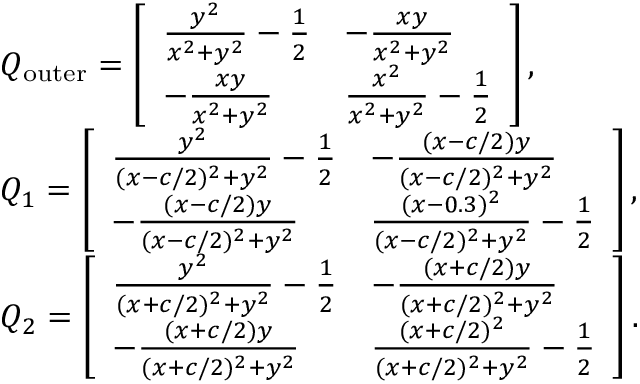Convert formula to latex. <formula><loc_0><loc_0><loc_500><loc_500>\begin{array} { r l } & { Q _ { o u t e r } = \left [ \begin{array} { l l } { \frac { y ^ { 2 } } { x ^ { 2 } + y ^ { 2 } } - \frac { 1 } { 2 } } & { - \frac { x y } { x ^ { 2 } + y ^ { 2 } } } \\ { - \frac { x y } { x ^ { 2 } + y ^ { 2 } } } & { \frac { x ^ { 2 } } { x ^ { 2 } + y ^ { 2 } } - \frac { 1 } { 2 } } \end{array} \right ] , } \\ & { Q _ { 1 } = \left [ \begin{array} { l l } { \frac { y ^ { 2 } } { ( x - c / 2 ) ^ { 2 } + y ^ { 2 } } - \frac { 1 } { 2 } } & { - \frac { ( x - c / 2 ) y } { ( x - c / 2 ) ^ { 2 } + y ^ { 2 } } } \\ { - \frac { ( x - c / 2 ) y } { ( x - c / 2 ) ^ { 2 } + y ^ { 2 } } } & { \frac { ( x - 0 . 3 ) ^ { 2 } } { ( x - c / 2 ) ^ { 2 } + y ^ { 2 } } - \frac { 1 } { 2 } } \end{array} \right ] , } \\ & { Q _ { 2 } = \left [ \begin{array} { l l } { \frac { y ^ { 2 } } { ( x + c / 2 ) ^ { 2 } + y ^ { 2 } } - \frac { 1 } { 2 } } & { - \frac { ( x + c / 2 ) y } { ( x + c / 2 ) ^ { 2 } + y ^ { 2 } } } \\ { - \frac { ( x + c / 2 ) y } { ( x + c / 2 ) ^ { 2 } + y ^ { 2 } } } & { \frac { ( x + c / 2 ) ^ { 2 } } { ( x + c / 2 ) ^ { 2 } + y ^ { 2 } } - \frac { 1 } { 2 } } \end{array} \right ] . } \end{array}</formula> 